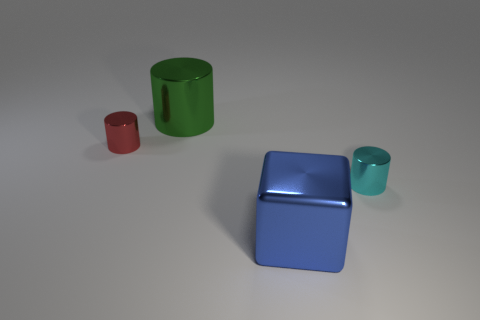Are there any tiny red shiny cylinders to the right of the red object?
Offer a terse response. No. Are there the same number of cyan things that are in front of the cyan shiny cylinder and large blue metal cubes?
Offer a very short reply. No. Are there any big blue things that are behind the big metal thing that is in front of the tiny cylinder in front of the small red shiny cylinder?
Your answer should be compact. No. What material is the tiny red object?
Your answer should be compact. Metal. How many other things are the same shape as the big green object?
Your answer should be very brief. 2. Is the tiny red metallic thing the same shape as the green thing?
Offer a very short reply. Yes. What number of things are either blue metal objects that are right of the green object or large things that are in front of the large green metallic object?
Your response must be concise. 1. What number of objects are red cylinders or red matte cubes?
Ensure brevity in your answer.  1. How many tiny red objects are on the right side of the large object that is in front of the big metallic cylinder?
Your response must be concise. 0. How many other objects are there of the same size as the cyan shiny thing?
Keep it short and to the point. 1. 